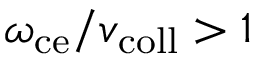Convert formula to latex. <formula><loc_0><loc_0><loc_500><loc_500>\omega _ { c e } / v _ { c o l l } > 1</formula> 